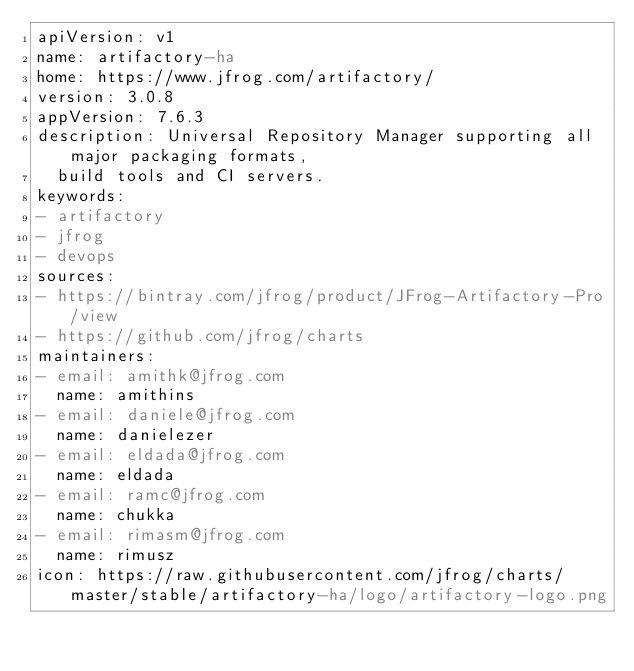<code> <loc_0><loc_0><loc_500><loc_500><_YAML_>apiVersion: v1
name: artifactory-ha
home: https://www.jfrog.com/artifactory/
version: 3.0.8
appVersion: 7.6.3
description: Universal Repository Manager supporting all major packaging formats,
  build tools and CI servers.
keywords:
- artifactory
- jfrog
- devops
sources:
- https://bintray.com/jfrog/product/JFrog-Artifactory-Pro/view
- https://github.com/jfrog/charts
maintainers:
- email: amithk@jfrog.com
  name: amithins
- email: daniele@jfrog.com
  name: danielezer
- email: eldada@jfrog.com
  name: eldada
- email: ramc@jfrog.com
  name: chukka
- email: rimasm@jfrog.com
  name: rimusz
icon: https://raw.githubusercontent.com/jfrog/charts/master/stable/artifactory-ha/logo/artifactory-logo.png
</code> 